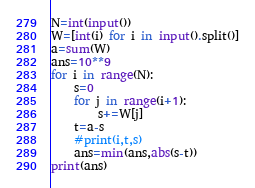Convert code to text. <code><loc_0><loc_0><loc_500><loc_500><_Python_>N=int(input())
W=[int(i) for i in input().split()]
a=sum(W)
ans=10**9
for i in range(N):
    s=0
    for j in range(i+1):
        s+=W[j]
    t=a-s
    #print(i,t,s)
    ans=min(ans,abs(s-t))
print(ans)</code> 